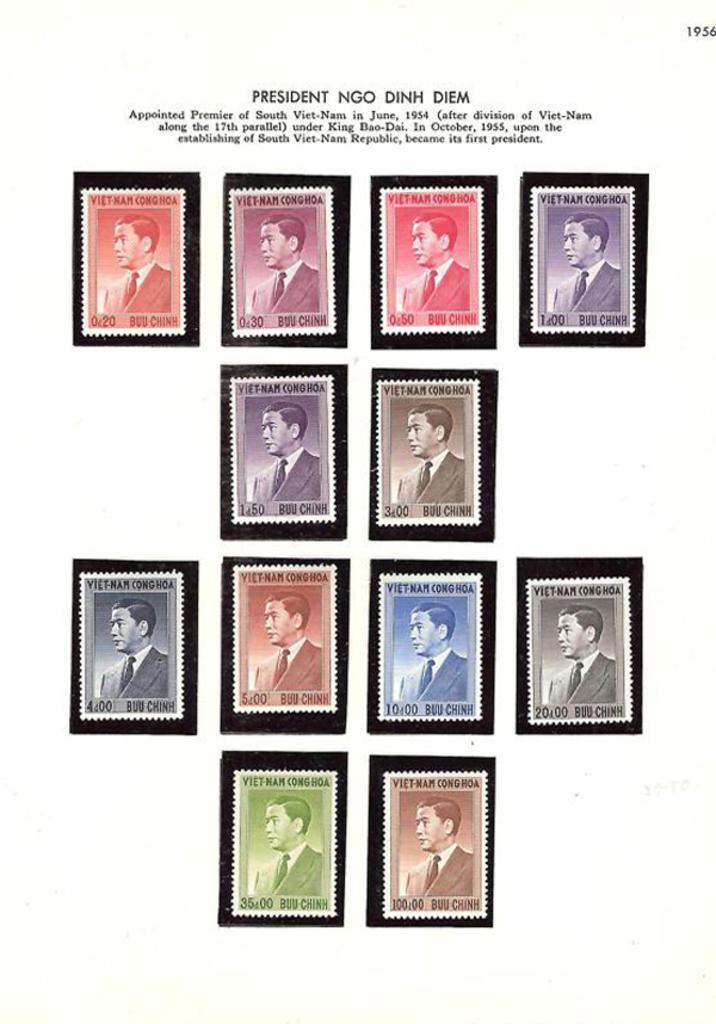Could you give a brief overview of what you see in this image? Here, we can see a picture of a man in different colors. 